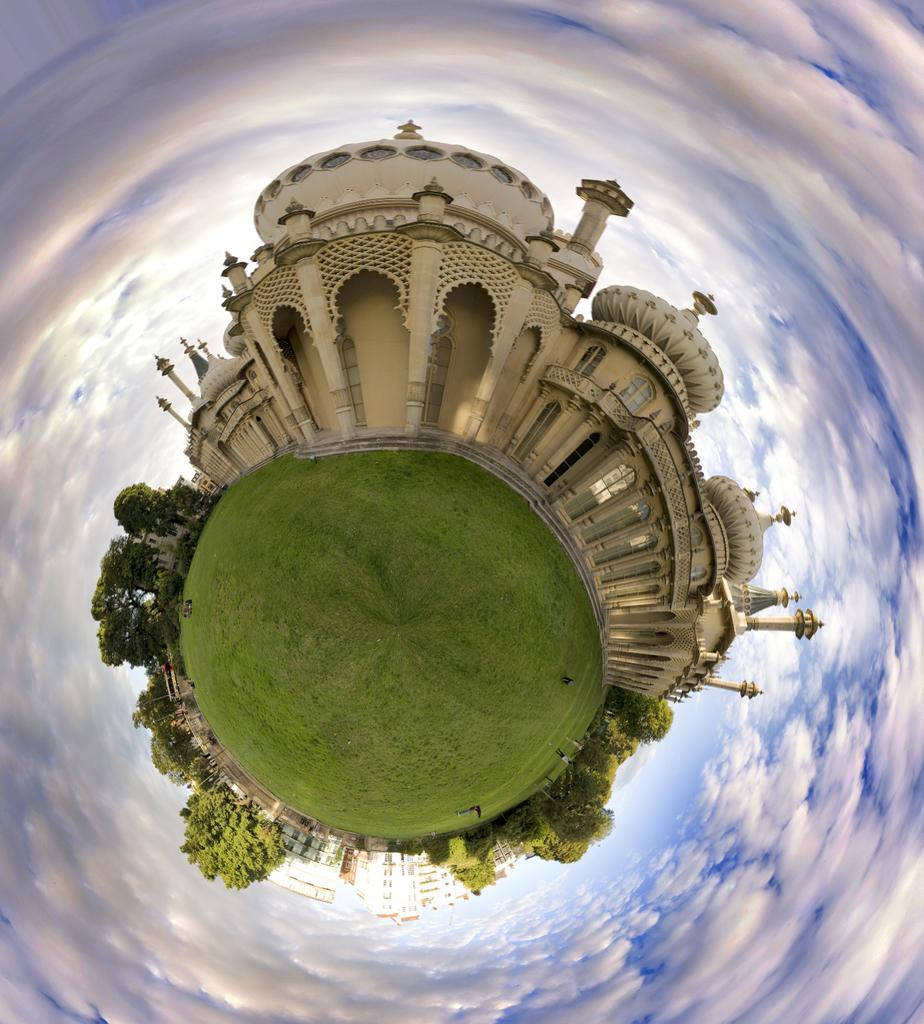What type of art is present in the image? The image contains a visual art piece. What type of structures can be seen in the image? There are buildings in the image. What type of vegetation is present in the image? There are trees and grass in the image. What are the people in the image wearing? The people in the image are wearing clothes. How would you describe the sky in the image? The sky is cloudy and blue in the image. How much water is visible in the image? There is no water visible in the image. What is the moon's position in the image? The moon is not present in the image. 